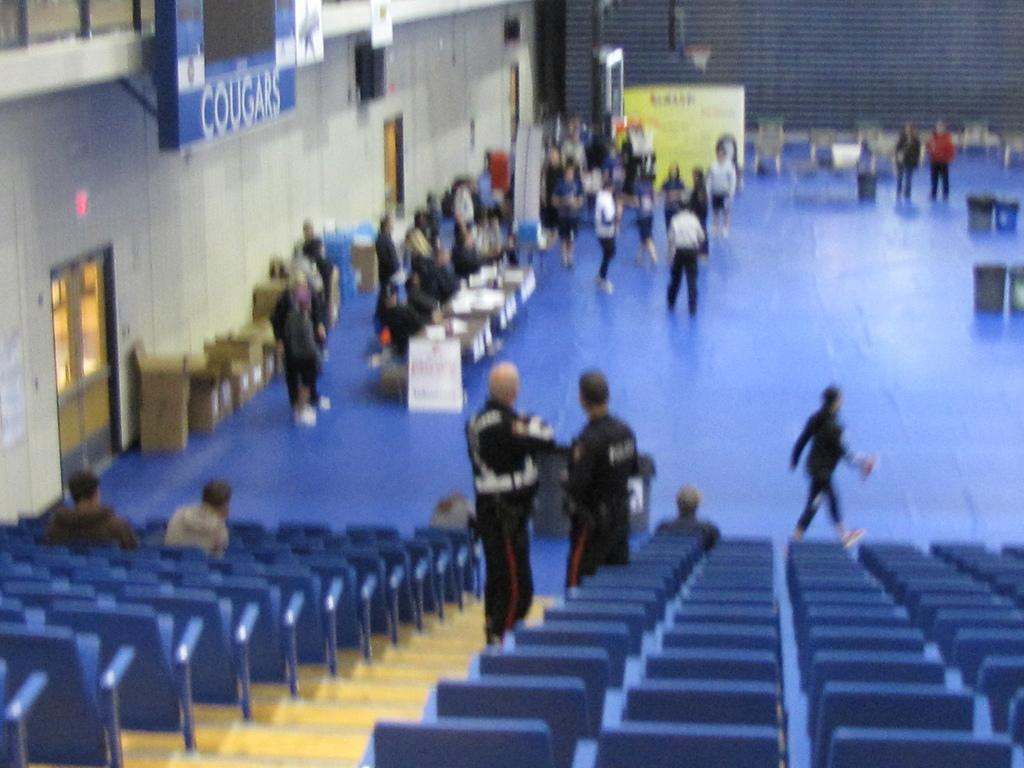What type of furniture is present in the image? There are chairs in the image. Can you describe the people in the image? There are people in the image. What other objects can be seen in the image? There are tables, hoardings, bins, cardboard boxes, and a door in the image. What type of oil is being used to create a sense of value in the image? There is no oil present in the image, nor is there any indication of creating a sense of value. 